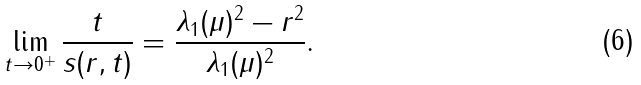Convert formula to latex. <formula><loc_0><loc_0><loc_500><loc_500>\lim _ { t \rightarrow 0 ^ { + } } \frac { t } { s ( r , t ) } = \frac { \lambda _ { 1 } ( \mu ) ^ { 2 } - r ^ { 2 } } { \lambda _ { 1 } ( \mu ) ^ { 2 } } .</formula> 